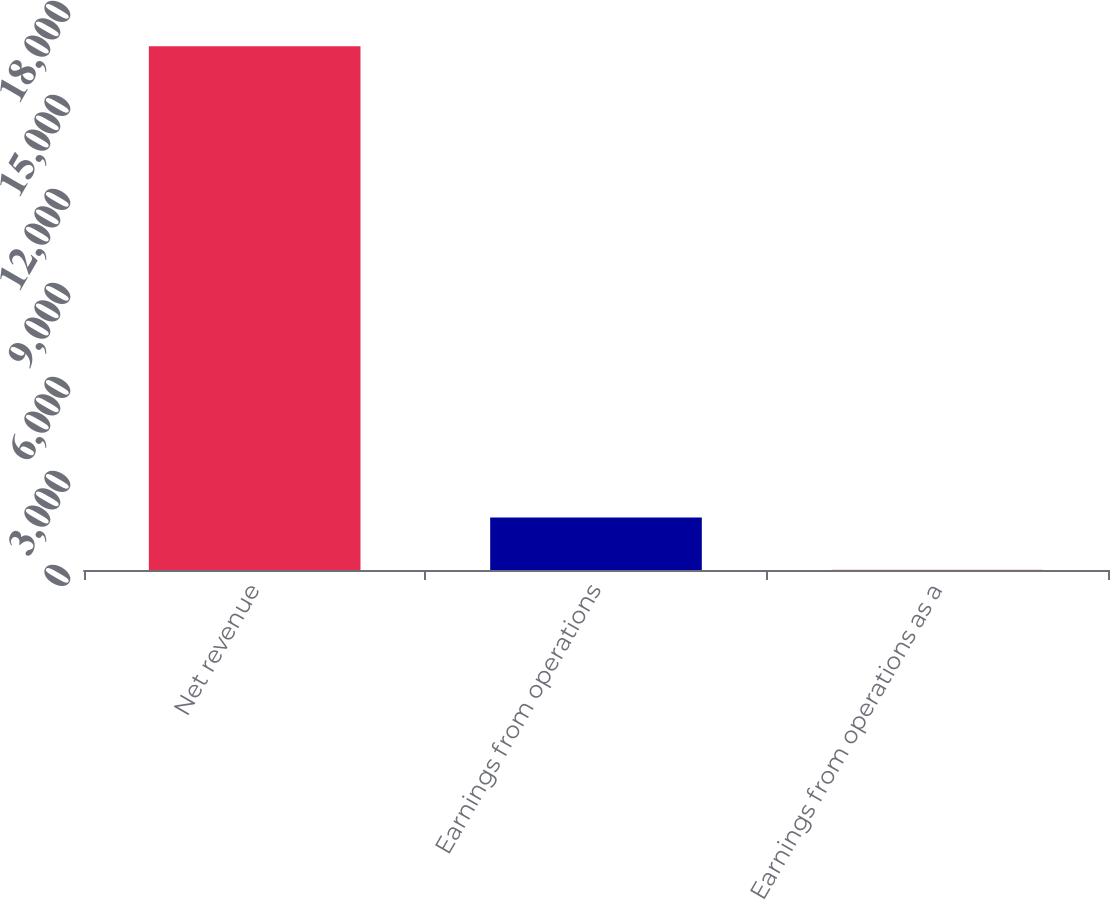Convert chart to OTSL. <chart><loc_0><loc_0><loc_500><loc_500><bar_chart><fcel>Net revenue<fcel>Earnings from operations<fcel>Earnings from operations as a<nl><fcel>16717<fcel>1676.02<fcel>4.8<nl></chart> 